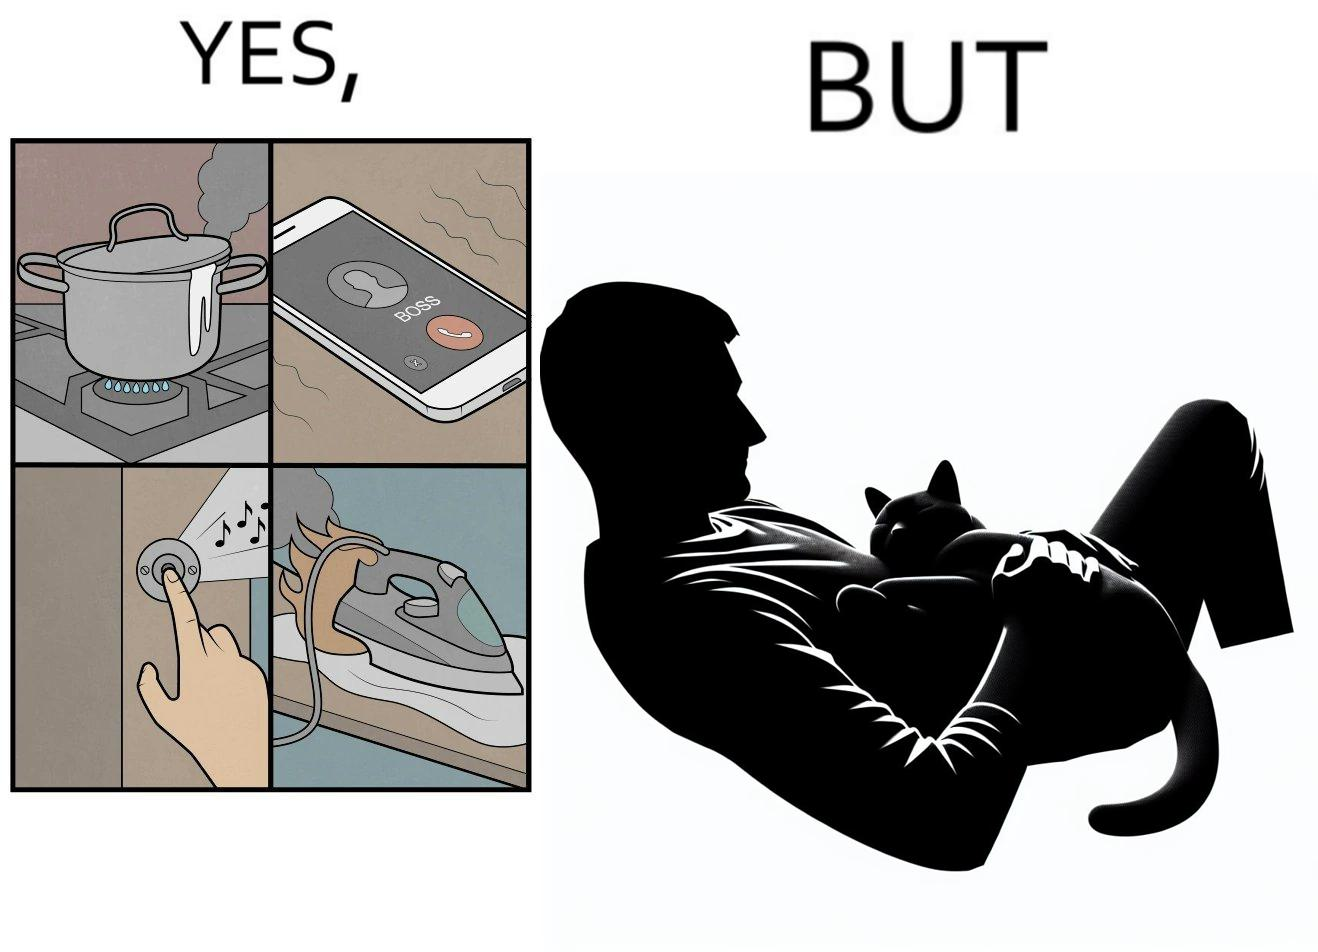Describe what you see in this image. the irony in this image is that people ignore all the chaos around them and get distracted by a cat. 